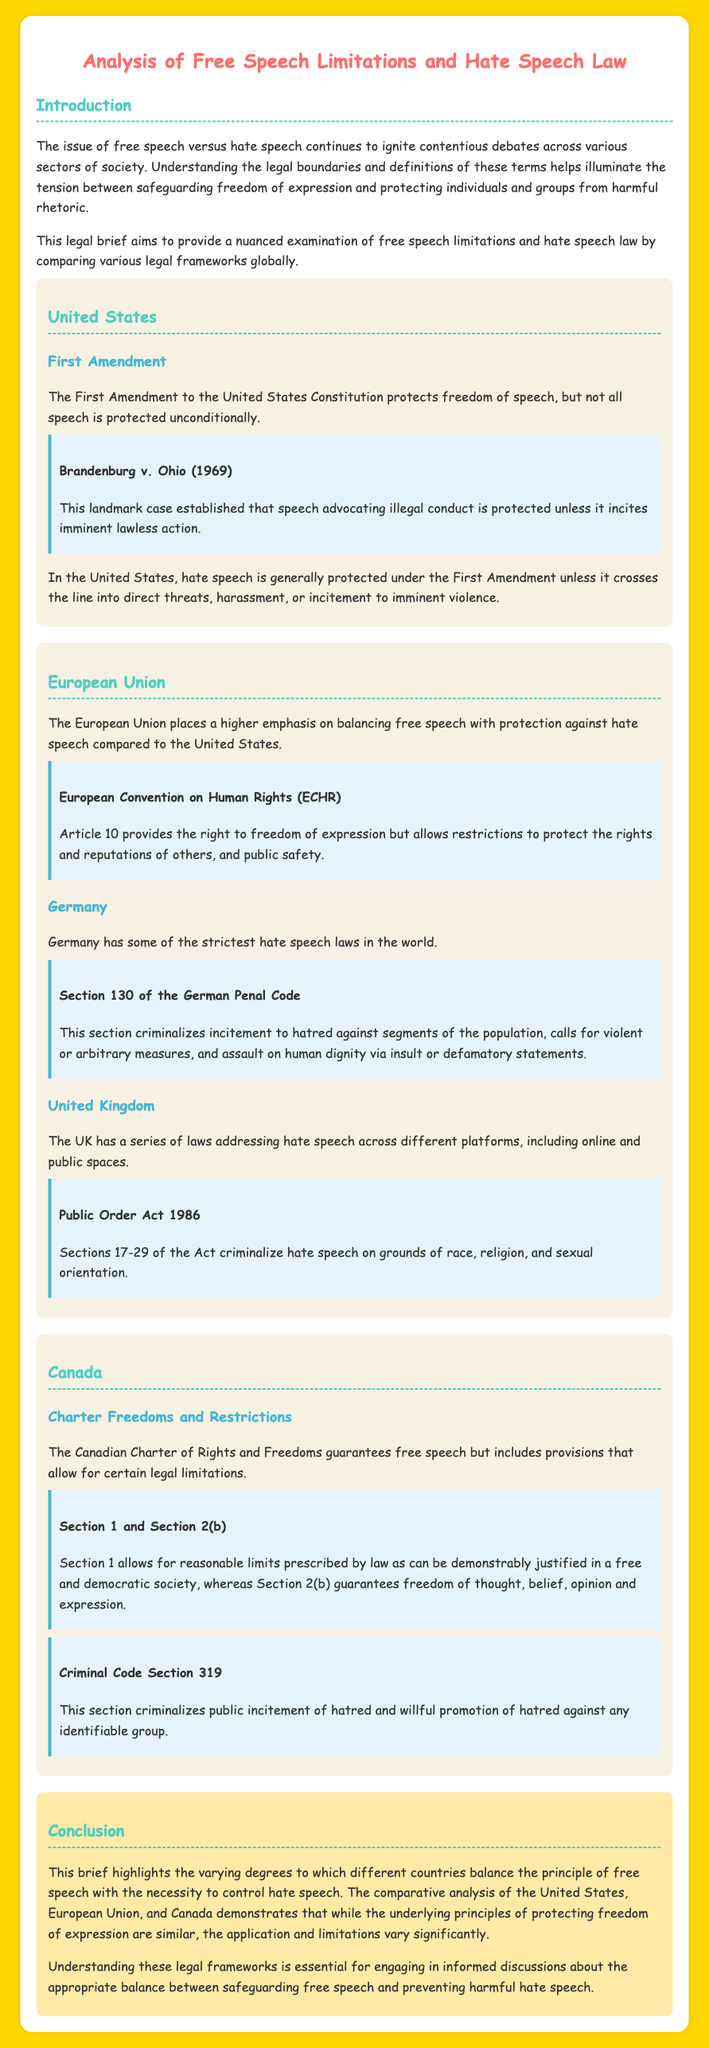What does the First Amendment protect? The First Amendment protects freedom of speech.
Answer: Freedom of speech What established that speech advocating illegal conduct is protected? Brandenburg v. Ohio (1969) is the landmark case that established this.
Answer: Brandenburg v. Ohio (1969) Which document allows for restrictions on free speech in the European Union? Article 10 of the European Convention on Human Rights allows for such restrictions.
Answer: Article 10 What does Section 130 of the German Penal Code criminalize? Section 130 criminalizes incitement to hatred against segments of the population.
Answer: Incitement to hatred How does Canada’s Charter of Rights and Freedoms address free speech? The Charter guarantees free speech while allowing for reasonable limits prescribed by law.
Answer: Reasonable limits What legal document in the UK addresses hate speech? The Public Order Act 1986 addresses hate speech in the UK.
Answer: Public Order Act 1986 What is Section 319 of the Canadian Criminal Code about? Section 319 criminalizes public incitement of hatred and willful promotion of hatred.
Answer: Public incitement of hatred What is the main focus of the discussed legal frameworks? The frameworks focus on balancing freedom of expression and protecting individuals from hate speech.
Answer: Balancing freedom of expression What is the common theme of free speech laws in the United States compared to Europe? The U.S. generally protects hate speech, while Europe emphasizes restrictions.
Answer: Protection vs restrictions 